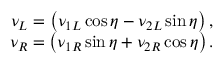<formula> <loc_0><loc_0><loc_500><loc_500>\begin{array} { c } { { \nu _ { L } = \left ( \nu _ { 1 L } \cos \eta - \nu _ { 2 L } \sin \eta \right ) , } } \\ { { \nu _ { R } = \left ( \nu _ { 1 R } \sin \eta + \nu _ { 2 R } \cos \eta \right ) . } } \end{array}</formula> 